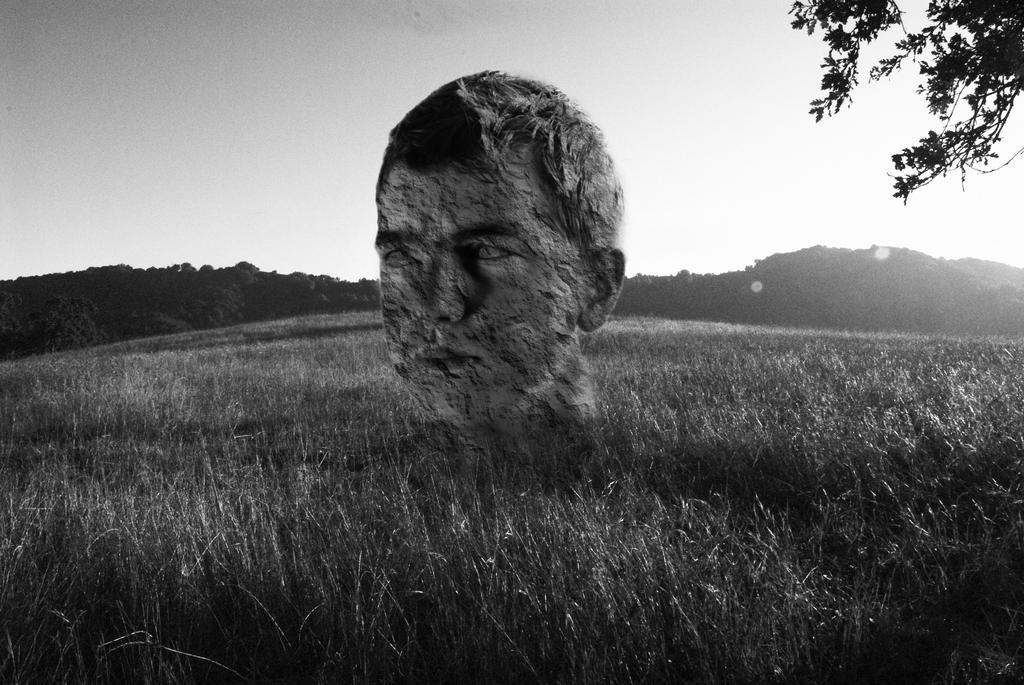In one or two sentences, can you explain what this image depicts? It is a black and white image. In this image we can see the depiction of a person. We can also see the grass, hills, trees and also the sky. 